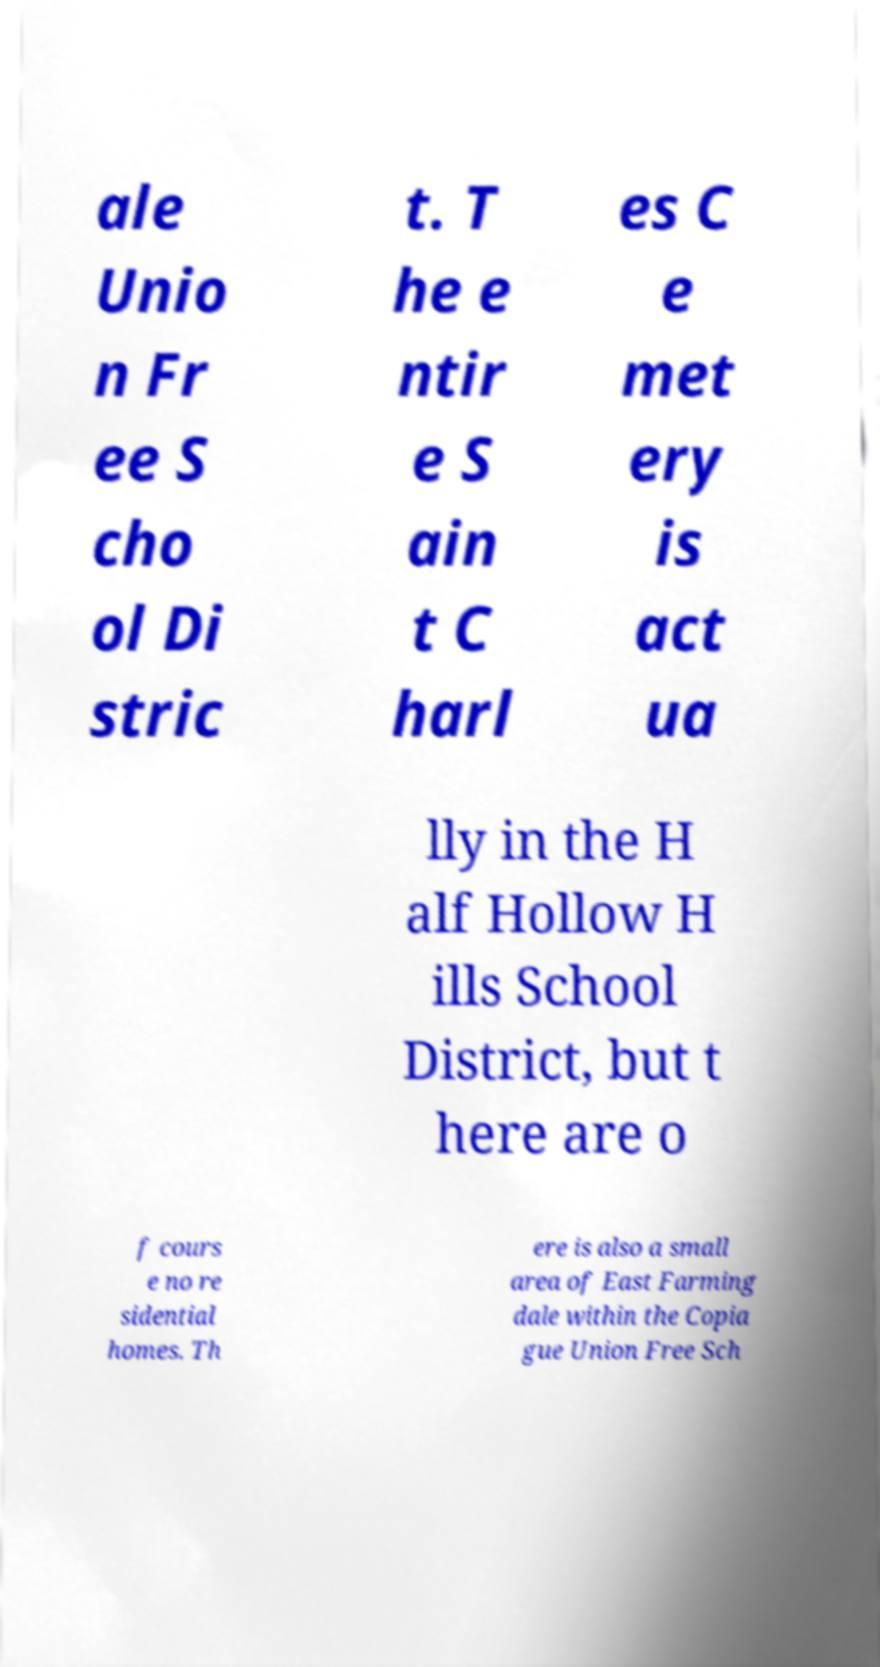What messages or text are displayed in this image? I need them in a readable, typed format. ale Unio n Fr ee S cho ol Di stric t. T he e ntir e S ain t C harl es C e met ery is act ua lly in the H alf Hollow H ills School District, but t here are o f cours e no re sidential homes. Th ere is also a small area of East Farming dale within the Copia gue Union Free Sch 